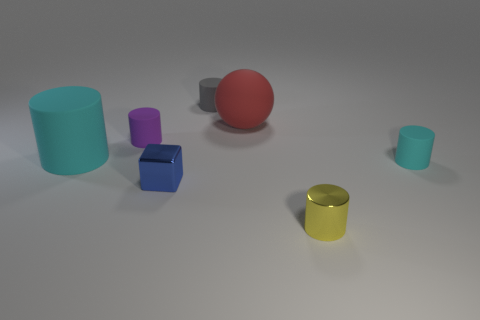Does the metallic block have the same color as the tiny matte cylinder in front of the big cyan rubber object?
Your answer should be very brief. No. Are there any tiny yellow blocks made of the same material as the small cyan cylinder?
Keep it short and to the point. No. What number of tiny blue blocks are there?
Ensure brevity in your answer.  1. There is a cyan object in front of the cyan thing that is on the left side of the tiny cyan rubber cylinder; what is it made of?
Give a very brief answer. Rubber. There is another large object that is made of the same material as the red object; what color is it?
Offer a very short reply. Cyan. There is a cyan rubber object that is to the right of the small gray cylinder; does it have the same size as the cyan cylinder behind the small cyan cylinder?
Provide a short and direct response. No. What number of cylinders are either cyan things or large red rubber objects?
Offer a terse response. 2. Are the big cyan thing that is in front of the red object and the tiny purple thing made of the same material?
Ensure brevity in your answer.  Yes. What number of other things are there of the same size as the metal cylinder?
Give a very brief answer. 4. What number of small objects are either purple objects or matte things?
Keep it short and to the point. 3. 